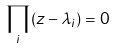Convert formula to latex. <formula><loc_0><loc_0><loc_500><loc_500>\prod _ { i } ( z - \lambda _ { i } ) = 0</formula> 